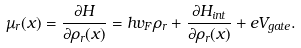Convert formula to latex. <formula><loc_0><loc_0><loc_500><loc_500>\mu _ { r } ( x ) = \frac { \partial H } { \partial \rho _ { r } ( x ) } = h v _ { F } \rho _ { r } + \frac { \partial H _ { i n t } } { \partial \rho _ { r } ( x ) } + e V _ { g a t e } .</formula> 